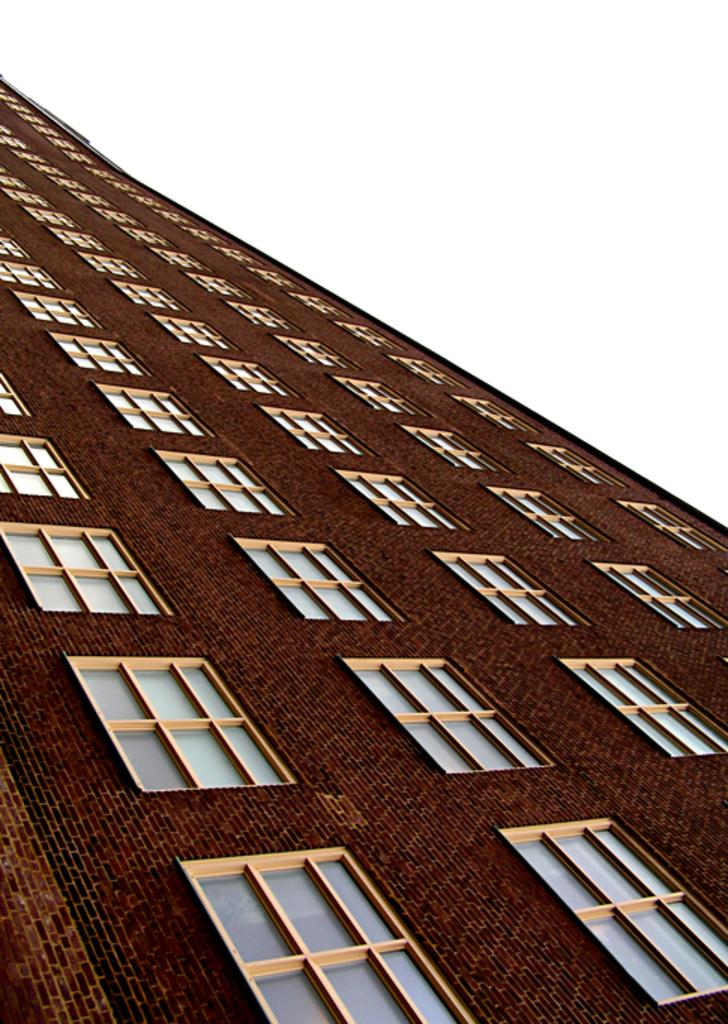What type of structure is present in the picture? There is a building in the picture. What is the color of the building? The building is brown in color. What material is the building made of? The building is made up of bricks. What type of windows does the building have? The building has glass windows. What is visible at the top of the picture? The sky is visible at the top of the picture. Can you see any muscles in the building's structure? There are no muscles present in the building's structure, as it is a man-made construction made of bricks and glass. 